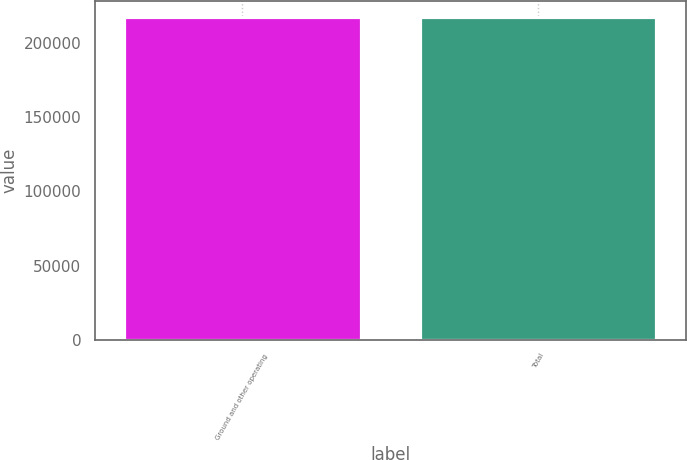Convert chart. <chart><loc_0><loc_0><loc_500><loc_500><bar_chart><fcel>Ground and other operating<fcel>Total<nl><fcel>217262<fcel>217262<nl></chart> 